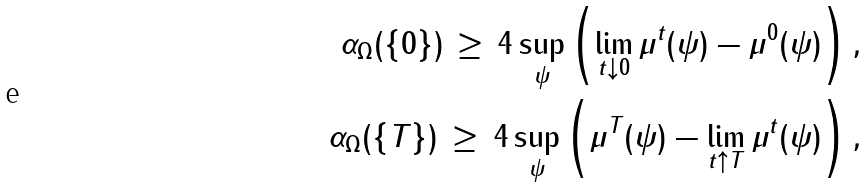Convert formula to latex. <formula><loc_0><loc_0><loc_500><loc_500>\alpha _ { \Omega } ( \{ 0 \} ) \, \geq \, 4 \sup _ { \psi } \left ( \lim _ { t \downarrow 0 } \mu ^ { t } ( \psi ) - \mu ^ { 0 } ( \psi ) \right ) , \\ \alpha _ { \Omega } ( \{ T \} ) \, \geq \, 4 \sup _ { \psi } \left ( \mu ^ { T } ( \psi ) - \lim _ { t \uparrow T } \mu ^ { t } ( \psi ) \right ) ,</formula> 